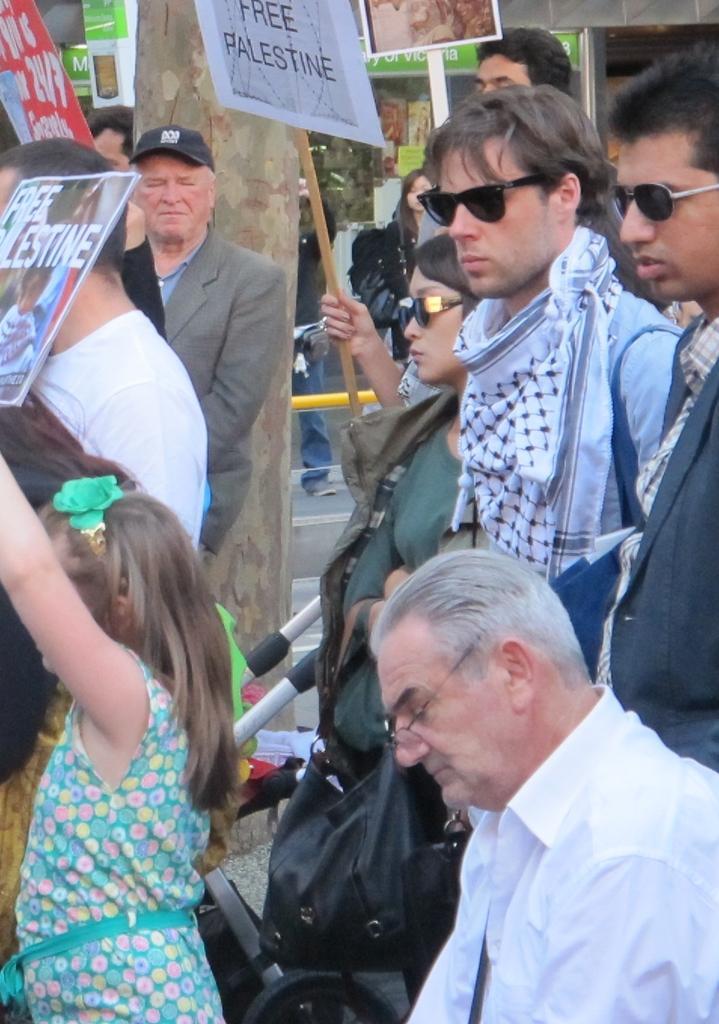How would you summarize this image in a sentence or two? In this image there are group of persons standing and sitting and holding placards with some text written on it. In the background there is a tree, there is railing which is yellow in colour and there are boards with some text written on it. 